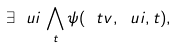<formula> <loc_0><loc_0><loc_500><loc_500>\exists \ u i \, \bigwedge _ { t } \psi ( \ t v , \ u i , t ) ,</formula> 